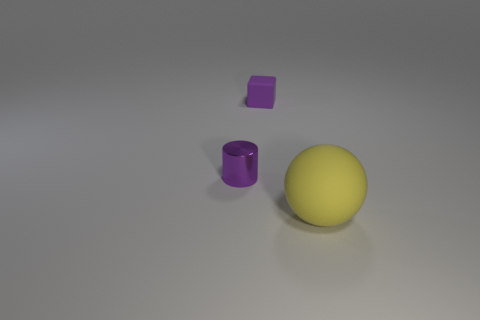What could be the relative materials of the objects based on their appearance? From the looks of it, the sphere seems to be made of a matte material, possibly plastic or rubber, given its solid yellow color. The cylinder has a metallic sheen, suggesting it could be made of metal. As for the cube, its uniform purple color and sharp edges could indicate a hard plastic or similarly painted material. 